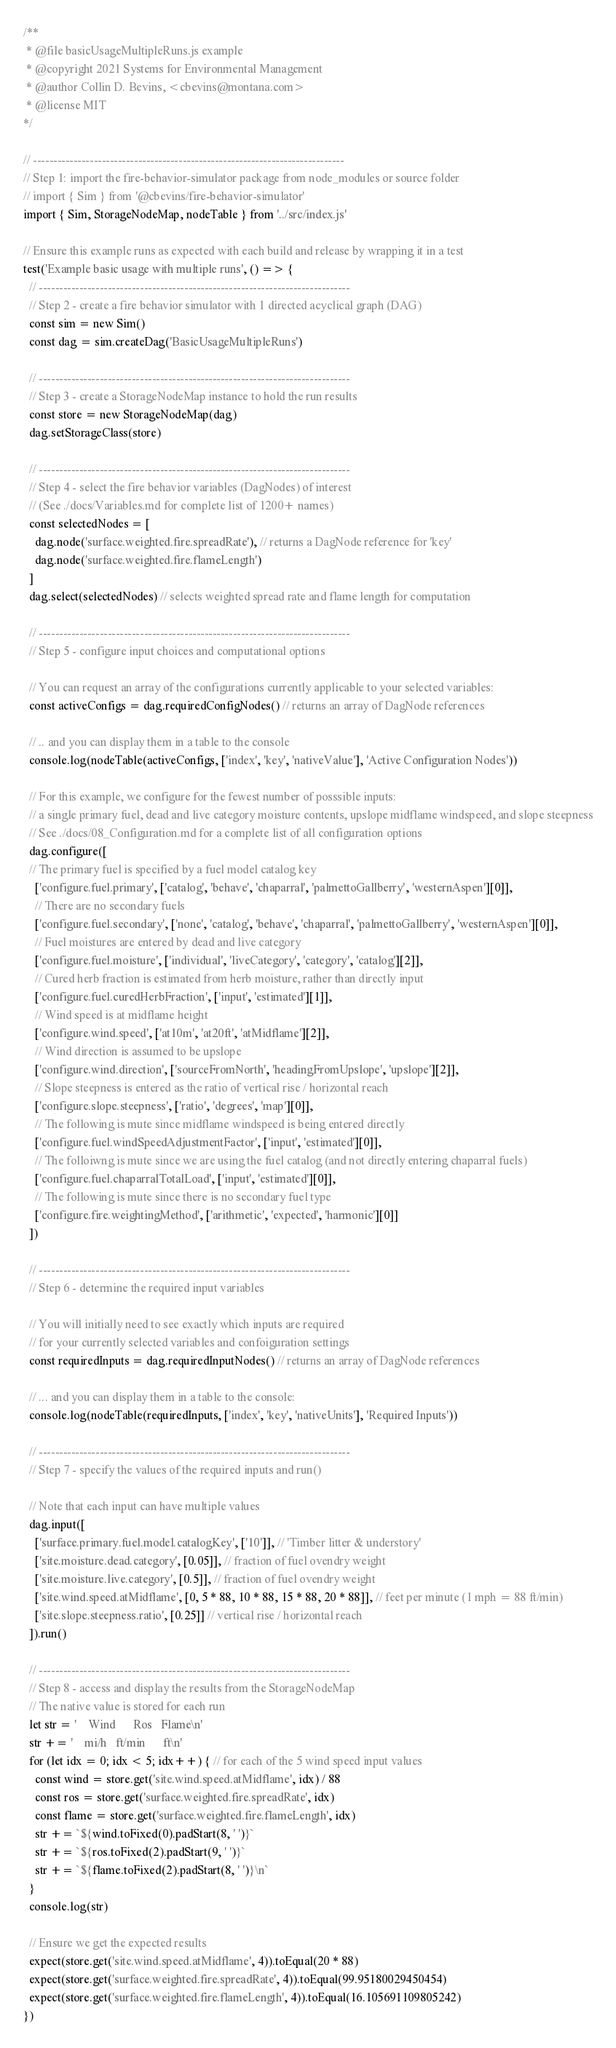Convert code to text. <code><loc_0><loc_0><loc_500><loc_500><_JavaScript_>/**
 * @file basicUsageMultipleRuns.js example
 * @copyright 2021 Systems for Environmental Management
 * @author Collin D. Bevins, <cbevins@montana.com>
 * @license MIT
*/

// -----------------------------------------------------------------------------
// Step 1: import the fire-behavior-simulator package from node_modules or source folder
// import { Sim } from '@cbevins/fire-behavior-simulator'
import { Sim, StorageNodeMap, nodeTable } from '../src/index.js'

// Ensure this example runs as expected with each build and release by wrapping it in a test
test('Example basic usage with multiple runs', () => {
  // -----------------------------------------------------------------------------
  // Step 2 - create a fire behavior simulator with 1 directed acyclical graph (DAG)
  const sim = new Sim()
  const dag = sim.createDag('BasicUsageMultipleRuns')

  // -----------------------------------------------------------------------------
  // Step 3 - create a StorageNodeMap instance to hold the run results
  const store = new StorageNodeMap(dag)
  dag.setStorageClass(store)

  // -----------------------------------------------------------------------------
  // Step 4 - select the fire behavior variables (DagNodes) of interest
  // (See ./docs/Variables.md for complete list of 1200+ names)
  const selectedNodes = [
    dag.node('surface.weighted.fire.spreadRate'), // returns a DagNode reference for 'key'
    dag.node('surface.weighted.fire.flameLength')
  ]
  dag.select(selectedNodes) // selects weighted spread rate and flame length for computation

  // -----------------------------------------------------------------------------
  // Step 5 - configure input choices and computational options

  // You can request an array of the configurations currently applicable to your selected variables:
  const activeConfigs = dag.requiredConfigNodes() // returns an array of DagNode references

  // .. and you can display them in a table to the console
  console.log(nodeTable(activeConfigs, ['index', 'key', 'nativeValue'], 'Active Configuration Nodes'))

  // For this example, we configure for the fewest number of posssible inputs:
  // a single primary fuel, dead and live category moisture contents, upslope midflame windspeed, and slope steepness
  // See ./docs/08_Configuration.md for a complete list of all configuration options
  dag.configure([
  // The primary fuel is specified by a fuel model catalog key
    ['configure.fuel.primary', ['catalog', 'behave', 'chaparral', 'palmettoGallberry', 'westernAspen'][0]],
    // There are no secondary fuels
    ['configure.fuel.secondary', ['none', 'catalog', 'behave', 'chaparral', 'palmettoGallberry', 'westernAspen'][0]],
    // Fuel moistures are entered by dead and live category
    ['configure.fuel.moisture', ['individual', 'liveCategory', 'category', 'catalog'][2]],
    // Cured herb fraction is estimated from herb moisture, rather than directly input
    ['configure.fuel.curedHerbFraction', ['input', 'estimated'][1]],
    // Wind speed is at midflame height
    ['configure.wind.speed', ['at10m', 'at20ft', 'atMidflame'][2]],
    // Wind direction is assumed to be upslope
    ['configure.wind.direction', ['sourceFromNorth', 'headingFromUpslope', 'upslope'][2]],
    // Slope steepness is entered as the ratio of vertical rise / horizontal reach
    ['configure.slope.steepness', ['ratio', 'degrees', 'map'][0]],
    // The following is mute since midflame windspeed is being entered directly
    ['configure.fuel.windSpeedAdjustmentFactor', ['input', 'estimated'][0]],
    // The folloiwng is mute since we are using the fuel catalog (and not directly entering chaparral fuels)
    ['configure.fuel.chaparralTotalLoad', ['input', 'estimated'][0]],
    // The following is mute since there is no secondary fuel type
    ['configure.fire.weightingMethod', ['arithmetic', 'expected', 'harmonic'][0]]
  ])

  // -----------------------------------------------------------------------------
  // Step 6 - determine the required input variables

  // You will initially need to see exactly which inputs are required
  // for your currently selected variables and confoiguration settings
  const requiredInputs = dag.requiredInputNodes() // returns an array of DagNode references

  // ... and you can display them in a table to the console:
  console.log(nodeTable(requiredInputs, ['index', 'key', 'nativeUnits'], 'Required Inputs'))

  // -----------------------------------------------------------------------------
  // Step 7 - specify the values of the required inputs and run()

  // Note that each input can have multiple values
  dag.input([
    ['surface.primary.fuel.model.catalogKey', ['10']], // 'Timber litter & understory'
    ['site.moisture.dead.category', [0.05]], // fraction of fuel ovendry weight
    ['site.moisture.live.category', [0.5]], // fraction of fuel ovendry weight
    ['site.wind.speed.atMidflame', [0, 5 * 88, 10 * 88, 15 * 88, 20 * 88]], // feet per minute (1 mph = 88 ft/min)
    ['site.slope.steepness.ratio', [0.25]] // vertical rise / horizontal reach
  ]).run()

  // -----------------------------------------------------------------------------
  // Step 8 - access and display the results from the StorageNodeMap
  // The native value is stored for each run
  let str = '    Wind      Ros   Flame\n'
  str += '    mi/h   ft/min      ft\n'
  for (let idx = 0; idx < 5; idx++) { // for each of the 5 wind speed input values
    const wind = store.get('site.wind.speed.atMidflame', idx) / 88
    const ros = store.get('surface.weighted.fire.spreadRate', idx)
    const flame = store.get('surface.weighted.fire.flameLength', idx)
    str += `${wind.toFixed(0).padStart(8, ' ')}`
    str += `${ros.toFixed(2).padStart(9, ' ')}`
    str += `${flame.toFixed(2).padStart(8, ' ')}\n`
  }
  console.log(str)

  // Ensure we get the expected results
  expect(store.get('site.wind.speed.atMidflame', 4)).toEqual(20 * 88)
  expect(store.get('surface.weighted.fire.spreadRate', 4)).toEqual(99.95180029450454)
  expect(store.get('surface.weighted.fire.flameLength', 4)).toEqual(16.105691109805242)
})
</code> 